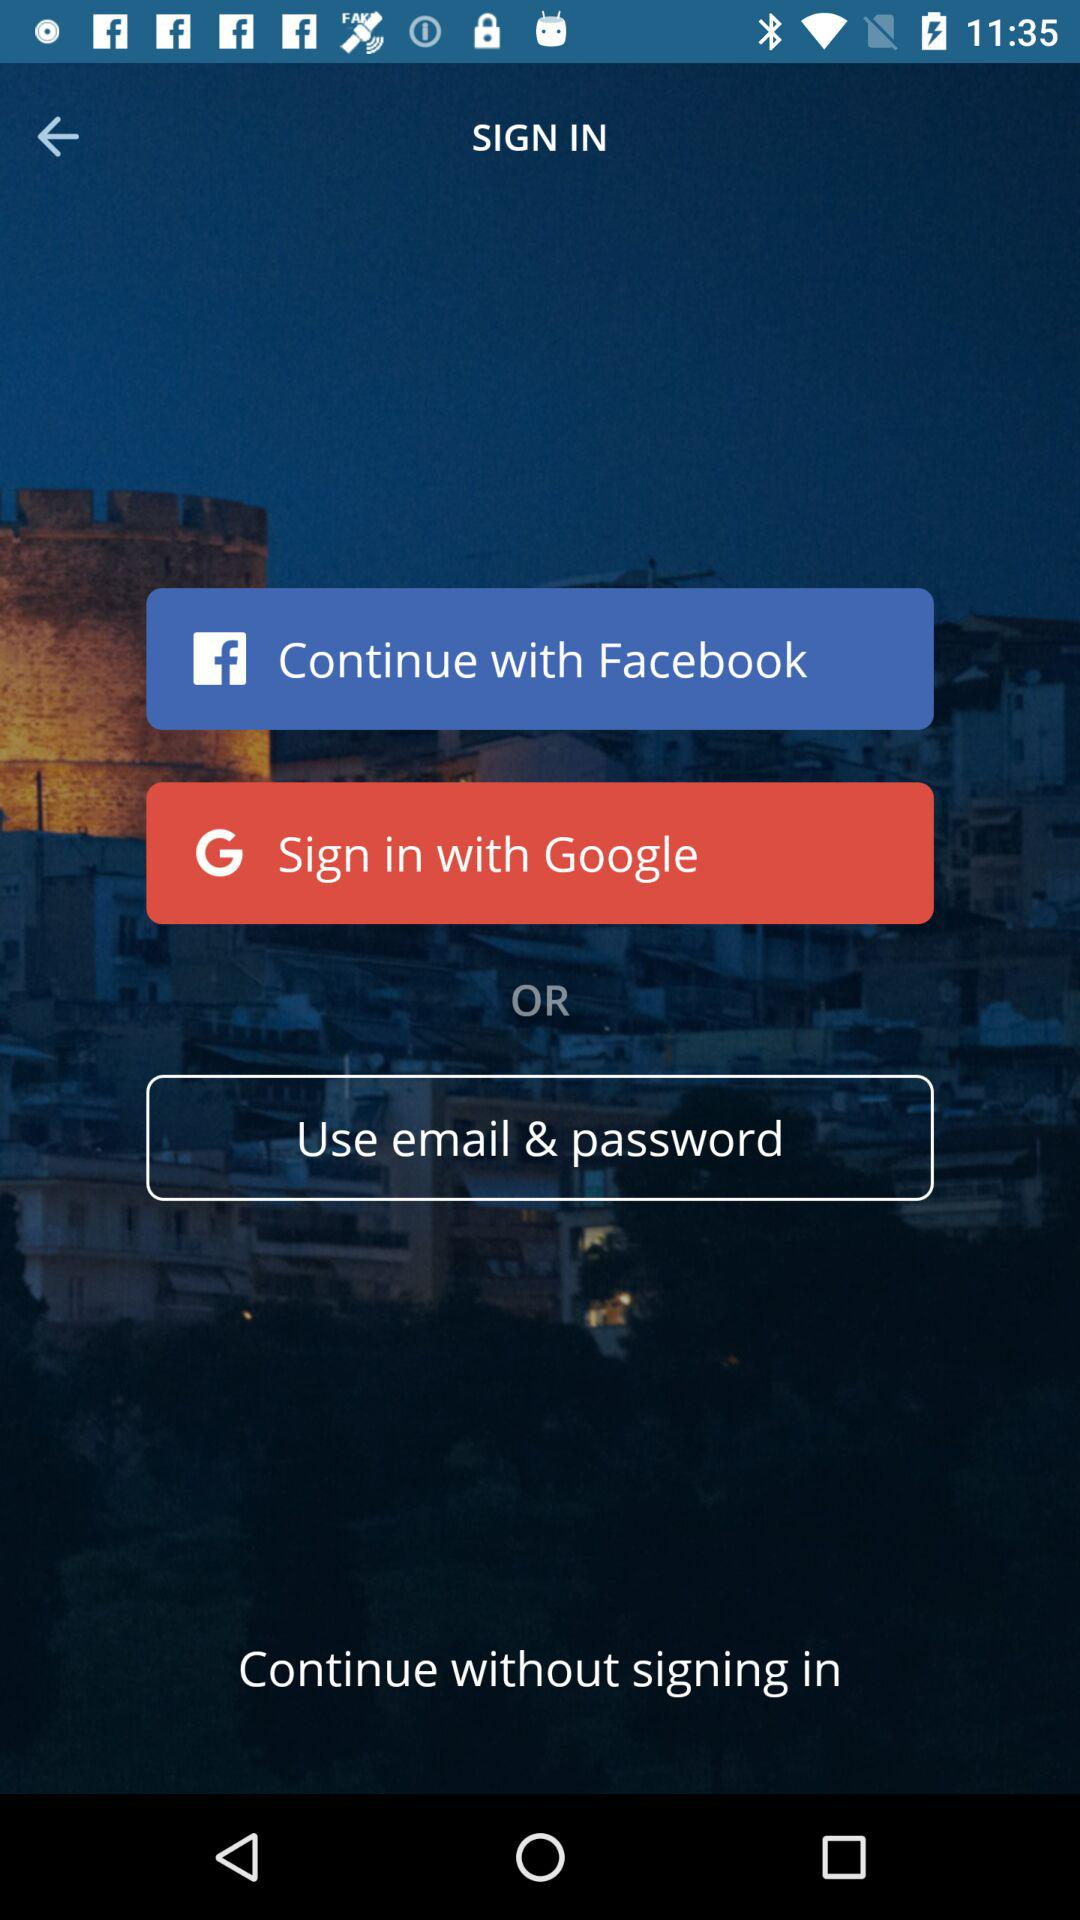Which applications can be used to sign in? The applications that can be used are "Facebook" and "Google". 